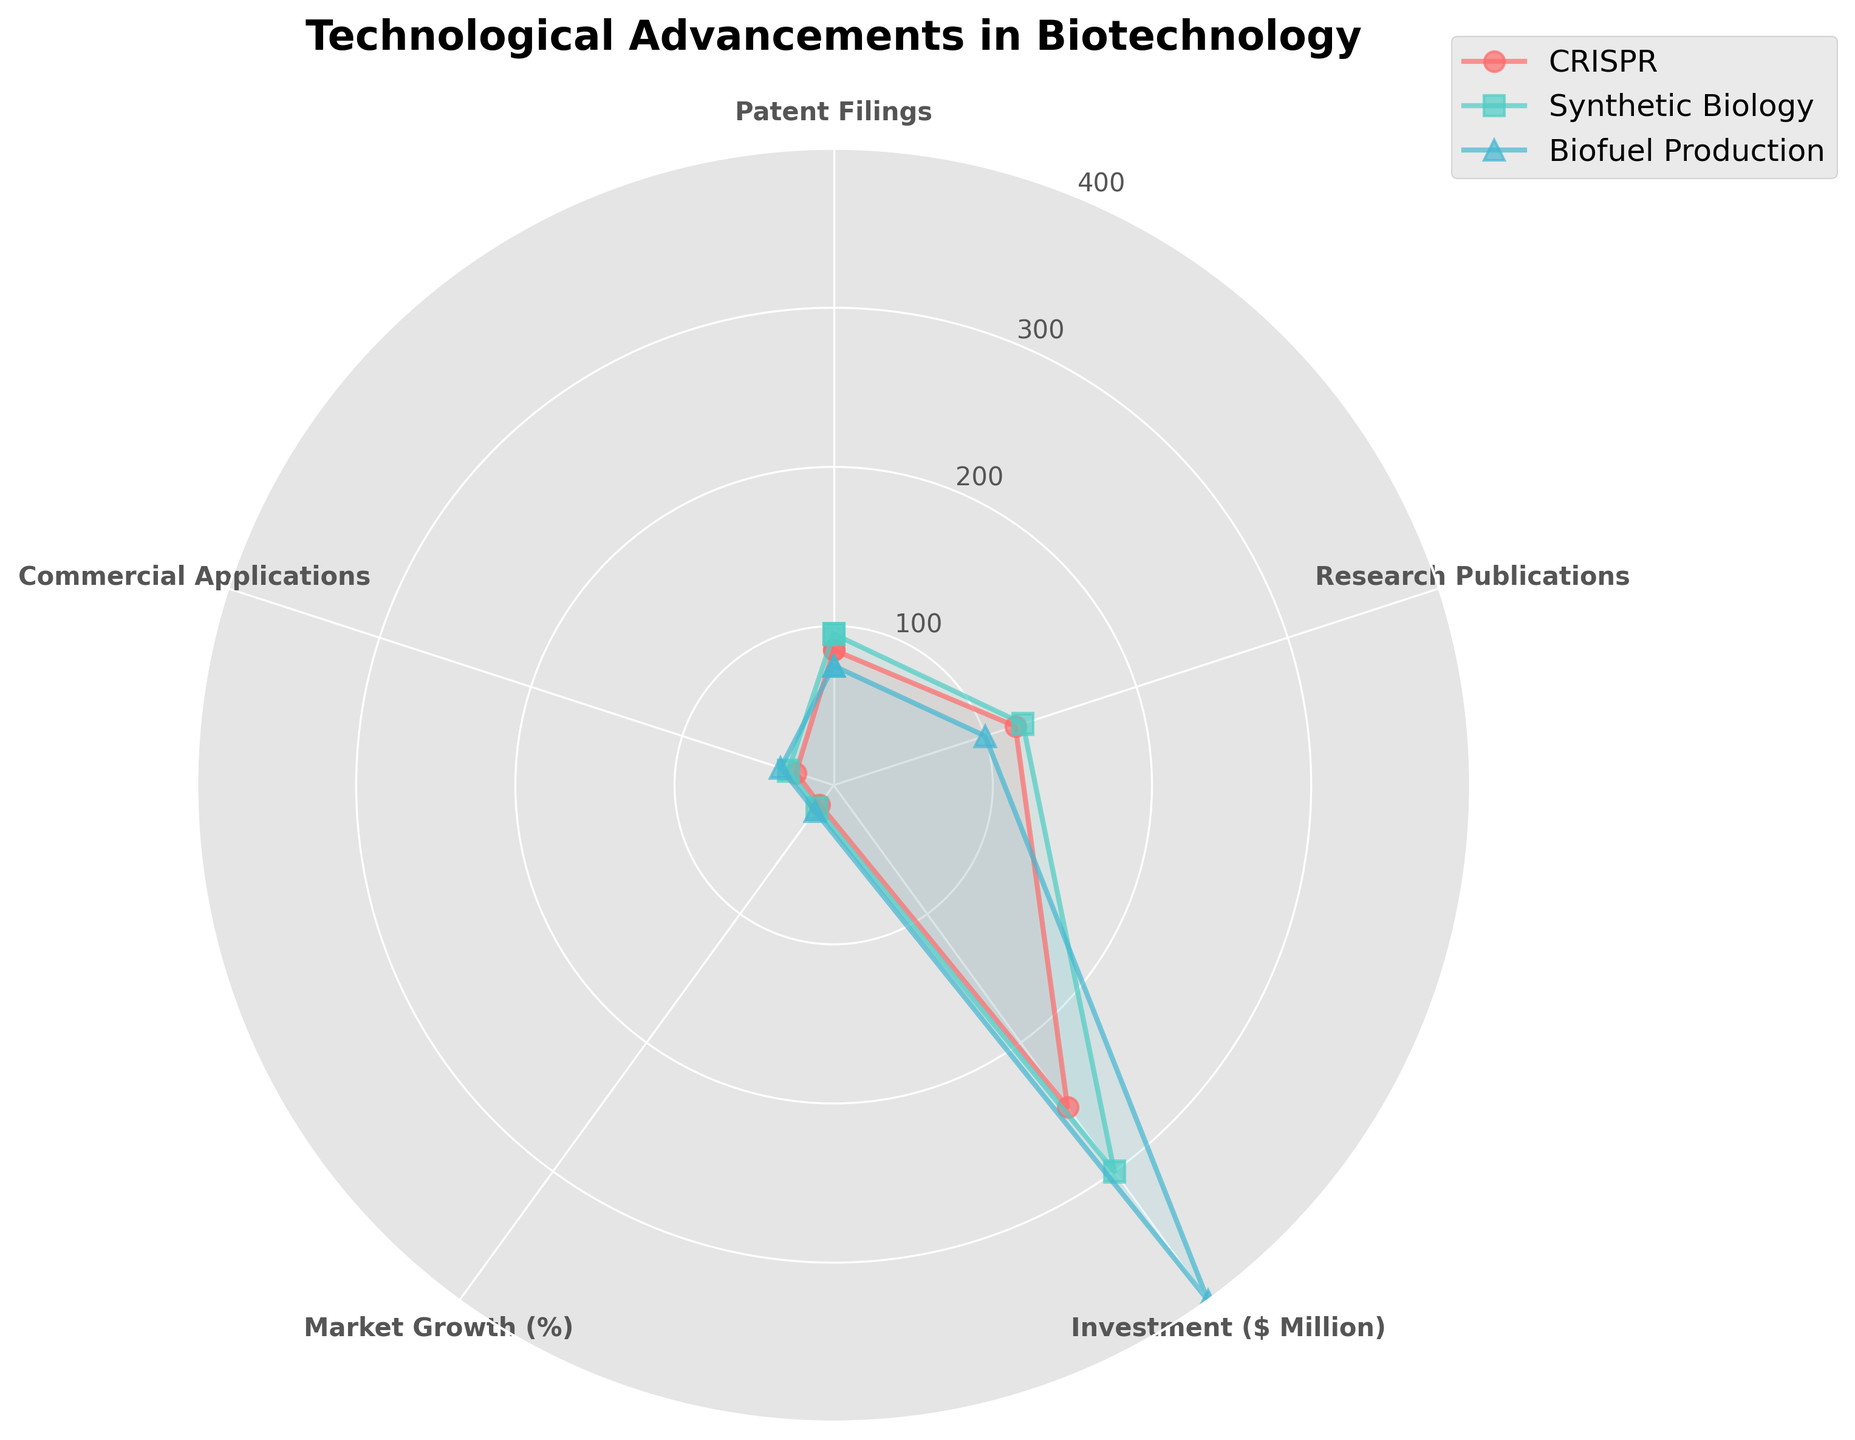What is the title of the plot? The title of the plot is located at the top of the figure, typically in bold and larger font. In this radar chart, the title is clearly labeled to give a summary of what the figure is about.
Answer: Technological Advancements in Biotechnology Which technology shows the highest value for Market Growth (%)? The Market Growth values are marked by different angles corresponding to different technologies. By looking at the lines and markers, the highest value for Market Growth is represented by the longest stretch in that category.
Answer: Biofuel Production Which technology has the most Research Publications? Research Publications are visually represented by the distance from the center for each technology on the Research Publications axis. The farthest marker on the Research Publications axis indicates the highest number.
Answer: CRISPR Compare the Commercial Applications of Synthetic Biology and Biofuel Production. Which one is higher? Commercial Applications values for Synthetic Biology and Biofuel Production can be visually inspected around their respective angles. The value corresponding to the higher reach from the center on the Commercial Applications axis is the higher one.
Answer: Biofuel Production Which technology has the least value for Research Publications? Compare the visual lengths of the values on the Research Publications axis for each technology. The smallest length will indicate the least value.
Answer: Biofuel Production How do the investments in Biofuel Production compare to those in CRISPR? Visualize the Investment values on the respective angles for Biofuel Production and CRISPR. Compare the lengths to determine which is higher.
Answer: Biofuel Production > CRISPR What is the median value of Patent Filings for the technologies? List the Patent Filings values: 85 (CRISPR), 95 (Synthetic Biology), 75 (Biofuel Production). Arrange in ascending order: 75, 85, 95. The median is the middle value.
Answer: 85 